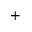Convert formula to latex. <formula><loc_0><loc_0><loc_500><loc_500>^ { + }</formula> 